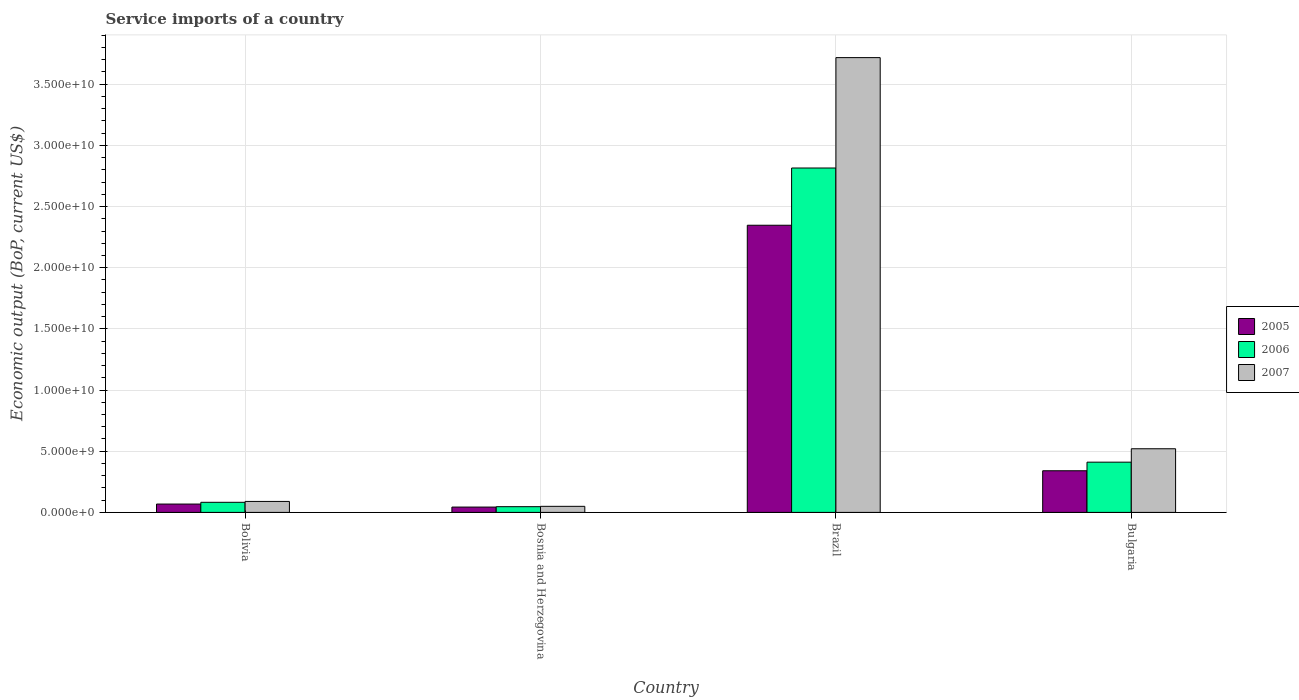How many different coloured bars are there?
Provide a short and direct response. 3. Are the number of bars on each tick of the X-axis equal?
Offer a very short reply. Yes. How many bars are there on the 2nd tick from the left?
Make the answer very short. 3. How many bars are there on the 1st tick from the right?
Keep it short and to the point. 3. What is the label of the 4th group of bars from the left?
Provide a short and direct response. Bulgaria. In how many cases, is the number of bars for a given country not equal to the number of legend labels?
Make the answer very short. 0. What is the service imports in 2007 in Bolivia?
Ensure brevity in your answer.  8.97e+08. Across all countries, what is the maximum service imports in 2007?
Make the answer very short. 3.72e+1. Across all countries, what is the minimum service imports in 2006?
Provide a succinct answer. 4.67e+08. In which country was the service imports in 2007 minimum?
Provide a succinct answer. Bosnia and Herzegovina. What is the total service imports in 2007 in the graph?
Your answer should be very brief. 4.38e+1. What is the difference between the service imports in 2005 in Bosnia and Herzegovina and that in Brazil?
Offer a terse response. -2.30e+1. What is the difference between the service imports in 2005 in Brazil and the service imports in 2006 in Bolivia?
Your answer should be compact. 2.26e+1. What is the average service imports in 2007 per country?
Your response must be concise. 1.09e+1. What is the difference between the service imports of/in 2005 and service imports of/in 2006 in Brazil?
Provide a succinct answer. -4.68e+09. What is the ratio of the service imports in 2007 in Bosnia and Herzegovina to that in Bulgaria?
Keep it short and to the point. 0.1. Is the difference between the service imports in 2005 in Bolivia and Bosnia and Herzegovina greater than the difference between the service imports in 2006 in Bolivia and Bosnia and Herzegovina?
Provide a succinct answer. No. What is the difference between the highest and the second highest service imports in 2006?
Provide a succinct answer. -3.28e+09. What is the difference between the highest and the lowest service imports in 2007?
Provide a succinct answer. 3.67e+1. In how many countries, is the service imports in 2006 greater than the average service imports in 2006 taken over all countries?
Offer a terse response. 1. What does the 1st bar from the right in Bolivia represents?
Make the answer very short. 2007. Is it the case that in every country, the sum of the service imports in 2005 and service imports in 2007 is greater than the service imports in 2006?
Make the answer very short. Yes. Are all the bars in the graph horizontal?
Provide a succinct answer. No. Are the values on the major ticks of Y-axis written in scientific E-notation?
Offer a very short reply. Yes. Does the graph contain any zero values?
Offer a very short reply. No. Does the graph contain grids?
Provide a short and direct response. Yes. How many legend labels are there?
Make the answer very short. 3. How are the legend labels stacked?
Your answer should be compact. Vertical. What is the title of the graph?
Your response must be concise. Service imports of a country. Does "1983" appear as one of the legend labels in the graph?
Offer a terse response. No. What is the label or title of the X-axis?
Your answer should be very brief. Country. What is the label or title of the Y-axis?
Offer a terse response. Economic output (BoP, current US$). What is the Economic output (BoP, current US$) of 2005 in Bolivia?
Your answer should be compact. 6.82e+08. What is the Economic output (BoP, current US$) of 2006 in Bolivia?
Your answer should be compact. 8.25e+08. What is the Economic output (BoP, current US$) of 2007 in Bolivia?
Offer a terse response. 8.97e+08. What is the Economic output (BoP, current US$) of 2005 in Bosnia and Herzegovina?
Make the answer very short. 4.36e+08. What is the Economic output (BoP, current US$) in 2006 in Bosnia and Herzegovina?
Your answer should be very brief. 4.67e+08. What is the Economic output (BoP, current US$) in 2007 in Bosnia and Herzegovina?
Your response must be concise. 4.95e+08. What is the Economic output (BoP, current US$) of 2005 in Brazil?
Your response must be concise. 2.35e+1. What is the Economic output (BoP, current US$) of 2006 in Brazil?
Your response must be concise. 2.81e+1. What is the Economic output (BoP, current US$) of 2007 in Brazil?
Provide a succinct answer. 3.72e+1. What is the Economic output (BoP, current US$) of 2005 in Bulgaria?
Give a very brief answer. 3.40e+09. What is the Economic output (BoP, current US$) of 2006 in Bulgaria?
Make the answer very short. 4.11e+09. What is the Economic output (BoP, current US$) in 2007 in Bulgaria?
Offer a very short reply. 5.20e+09. Across all countries, what is the maximum Economic output (BoP, current US$) in 2005?
Ensure brevity in your answer.  2.35e+1. Across all countries, what is the maximum Economic output (BoP, current US$) of 2006?
Give a very brief answer. 2.81e+1. Across all countries, what is the maximum Economic output (BoP, current US$) in 2007?
Ensure brevity in your answer.  3.72e+1. Across all countries, what is the minimum Economic output (BoP, current US$) in 2005?
Keep it short and to the point. 4.36e+08. Across all countries, what is the minimum Economic output (BoP, current US$) of 2006?
Make the answer very short. 4.67e+08. Across all countries, what is the minimum Economic output (BoP, current US$) in 2007?
Your answer should be very brief. 4.95e+08. What is the total Economic output (BoP, current US$) of 2005 in the graph?
Your answer should be very brief. 2.80e+1. What is the total Economic output (BoP, current US$) of 2006 in the graph?
Make the answer very short. 3.35e+1. What is the total Economic output (BoP, current US$) of 2007 in the graph?
Offer a very short reply. 4.38e+1. What is the difference between the Economic output (BoP, current US$) in 2005 in Bolivia and that in Bosnia and Herzegovina?
Your response must be concise. 2.46e+08. What is the difference between the Economic output (BoP, current US$) of 2006 in Bolivia and that in Bosnia and Herzegovina?
Offer a terse response. 3.58e+08. What is the difference between the Economic output (BoP, current US$) of 2007 in Bolivia and that in Bosnia and Herzegovina?
Keep it short and to the point. 4.01e+08. What is the difference between the Economic output (BoP, current US$) in 2005 in Bolivia and that in Brazil?
Your answer should be compact. -2.28e+1. What is the difference between the Economic output (BoP, current US$) in 2006 in Bolivia and that in Brazil?
Ensure brevity in your answer.  -2.73e+1. What is the difference between the Economic output (BoP, current US$) in 2007 in Bolivia and that in Brazil?
Offer a very short reply. -3.63e+1. What is the difference between the Economic output (BoP, current US$) in 2005 in Bolivia and that in Bulgaria?
Give a very brief answer. -2.72e+09. What is the difference between the Economic output (BoP, current US$) in 2006 in Bolivia and that in Bulgaria?
Ensure brevity in your answer.  -3.28e+09. What is the difference between the Economic output (BoP, current US$) of 2007 in Bolivia and that in Bulgaria?
Keep it short and to the point. -4.31e+09. What is the difference between the Economic output (BoP, current US$) in 2005 in Bosnia and Herzegovina and that in Brazil?
Provide a succinct answer. -2.30e+1. What is the difference between the Economic output (BoP, current US$) of 2006 in Bosnia and Herzegovina and that in Brazil?
Offer a very short reply. -2.77e+1. What is the difference between the Economic output (BoP, current US$) in 2007 in Bosnia and Herzegovina and that in Brazil?
Give a very brief answer. -3.67e+1. What is the difference between the Economic output (BoP, current US$) in 2005 in Bosnia and Herzegovina and that in Bulgaria?
Provide a short and direct response. -2.97e+09. What is the difference between the Economic output (BoP, current US$) in 2006 in Bosnia and Herzegovina and that in Bulgaria?
Provide a succinct answer. -3.64e+09. What is the difference between the Economic output (BoP, current US$) in 2007 in Bosnia and Herzegovina and that in Bulgaria?
Give a very brief answer. -4.71e+09. What is the difference between the Economic output (BoP, current US$) of 2005 in Brazil and that in Bulgaria?
Your answer should be compact. 2.01e+1. What is the difference between the Economic output (BoP, current US$) in 2006 in Brazil and that in Bulgaria?
Offer a terse response. 2.40e+1. What is the difference between the Economic output (BoP, current US$) of 2007 in Brazil and that in Bulgaria?
Your response must be concise. 3.20e+1. What is the difference between the Economic output (BoP, current US$) of 2005 in Bolivia and the Economic output (BoP, current US$) of 2006 in Bosnia and Herzegovina?
Offer a terse response. 2.15e+08. What is the difference between the Economic output (BoP, current US$) in 2005 in Bolivia and the Economic output (BoP, current US$) in 2007 in Bosnia and Herzegovina?
Ensure brevity in your answer.  1.87e+08. What is the difference between the Economic output (BoP, current US$) in 2006 in Bolivia and the Economic output (BoP, current US$) in 2007 in Bosnia and Herzegovina?
Make the answer very short. 3.29e+08. What is the difference between the Economic output (BoP, current US$) of 2005 in Bolivia and the Economic output (BoP, current US$) of 2006 in Brazil?
Offer a very short reply. -2.75e+1. What is the difference between the Economic output (BoP, current US$) in 2005 in Bolivia and the Economic output (BoP, current US$) in 2007 in Brazil?
Your answer should be compact. -3.65e+1. What is the difference between the Economic output (BoP, current US$) of 2006 in Bolivia and the Economic output (BoP, current US$) of 2007 in Brazil?
Your answer should be compact. -3.63e+1. What is the difference between the Economic output (BoP, current US$) in 2005 in Bolivia and the Economic output (BoP, current US$) in 2006 in Bulgaria?
Provide a succinct answer. -3.42e+09. What is the difference between the Economic output (BoP, current US$) of 2005 in Bolivia and the Economic output (BoP, current US$) of 2007 in Bulgaria?
Offer a terse response. -4.52e+09. What is the difference between the Economic output (BoP, current US$) in 2006 in Bolivia and the Economic output (BoP, current US$) in 2007 in Bulgaria?
Keep it short and to the point. -4.38e+09. What is the difference between the Economic output (BoP, current US$) of 2005 in Bosnia and Herzegovina and the Economic output (BoP, current US$) of 2006 in Brazil?
Provide a short and direct response. -2.77e+1. What is the difference between the Economic output (BoP, current US$) of 2005 in Bosnia and Herzegovina and the Economic output (BoP, current US$) of 2007 in Brazil?
Provide a short and direct response. -3.67e+1. What is the difference between the Economic output (BoP, current US$) in 2006 in Bosnia and Herzegovina and the Economic output (BoP, current US$) in 2007 in Brazil?
Your response must be concise. -3.67e+1. What is the difference between the Economic output (BoP, current US$) of 2005 in Bosnia and Herzegovina and the Economic output (BoP, current US$) of 2006 in Bulgaria?
Offer a terse response. -3.67e+09. What is the difference between the Economic output (BoP, current US$) in 2005 in Bosnia and Herzegovina and the Economic output (BoP, current US$) in 2007 in Bulgaria?
Your response must be concise. -4.77e+09. What is the difference between the Economic output (BoP, current US$) of 2006 in Bosnia and Herzegovina and the Economic output (BoP, current US$) of 2007 in Bulgaria?
Your answer should be very brief. -4.74e+09. What is the difference between the Economic output (BoP, current US$) of 2005 in Brazil and the Economic output (BoP, current US$) of 2006 in Bulgaria?
Your answer should be very brief. 1.94e+1. What is the difference between the Economic output (BoP, current US$) of 2005 in Brazil and the Economic output (BoP, current US$) of 2007 in Bulgaria?
Offer a very short reply. 1.83e+1. What is the difference between the Economic output (BoP, current US$) of 2006 in Brazil and the Economic output (BoP, current US$) of 2007 in Bulgaria?
Your answer should be compact. 2.29e+1. What is the average Economic output (BoP, current US$) of 2005 per country?
Provide a succinct answer. 7.00e+09. What is the average Economic output (BoP, current US$) in 2006 per country?
Provide a succinct answer. 8.39e+09. What is the average Economic output (BoP, current US$) in 2007 per country?
Ensure brevity in your answer.  1.09e+1. What is the difference between the Economic output (BoP, current US$) of 2005 and Economic output (BoP, current US$) of 2006 in Bolivia?
Provide a short and direct response. -1.43e+08. What is the difference between the Economic output (BoP, current US$) of 2005 and Economic output (BoP, current US$) of 2007 in Bolivia?
Provide a succinct answer. -2.15e+08. What is the difference between the Economic output (BoP, current US$) of 2006 and Economic output (BoP, current US$) of 2007 in Bolivia?
Your answer should be very brief. -7.19e+07. What is the difference between the Economic output (BoP, current US$) of 2005 and Economic output (BoP, current US$) of 2006 in Bosnia and Herzegovina?
Offer a very short reply. -3.12e+07. What is the difference between the Economic output (BoP, current US$) in 2005 and Economic output (BoP, current US$) in 2007 in Bosnia and Herzegovina?
Offer a very short reply. -5.97e+07. What is the difference between the Economic output (BoP, current US$) of 2006 and Economic output (BoP, current US$) of 2007 in Bosnia and Herzegovina?
Offer a terse response. -2.86e+07. What is the difference between the Economic output (BoP, current US$) in 2005 and Economic output (BoP, current US$) in 2006 in Brazil?
Offer a very short reply. -4.68e+09. What is the difference between the Economic output (BoP, current US$) in 2005 and Economic output (BoP, current US$) in 2007 in Brazil?
Provide a succinct answer. -1.37e+1. What is the difference between the Economic output (BoP, current US$) in 2006 and Economic output (BoP, current US$) in 2007 in Brazil?
Your answer should be compact. -9.02e+09. What is the difference between the Economic output (BoP, current US$) in 2005 and Economic output (BoP, current US$) in 2006 in Bulgaria?
Make the answer very short. -7.02e+08. What is the difference between the Economic output (BoP, current US$) in 2005 and Economic output (BoP, current US$) in 2007 in Bulgaria?
Your response must be concise. -1.80e+09. What is the difference between the Economic output (BoP, current US$) in 2006 and Economic output (BoP, current US$) in 2007 in Bulgaria?
Offer a terse response. -1.10e+09. What is the ratio of the Economic output (BoP, current US$) of 2005 in Bolivia to that in Bosnia and Herzegovina?
Make the answer very short. 1.57. What is the ratio of the Economic output (BoP, current US$) in 2006 in Bolivia to that in Bosnia and Herzegovina?
Your answer should be very brief. 1.77. What is the ratio of the Economic output (BoP, current US$) in 2007 in Bolivia to that in Bosnia and Herzegovina?
Give a very brief answer. 1.81. What is the ratio of the Economic output (BoP, current US$) of 2005 in Bolivia to that in Brazil?
Give a very brief answer. 0.03. What is the ratio of the Economic output (BoP, current US$) in 2006 in Bolivia to that in Brazil?
Offer a terse response. 0.03. What is the ratio of the Economic output (BoP, current US$) of 2007 in Bolivia to that in Brazil?
Keep it short and to the point. 0.02. What is the ratio of the Economic output (BoP, current US$) of 2005 in Bolivia to that in Bulgaria?
Provide a succinct answer. 0.2. What is the ratio of the Economic output (BoP, current US$) in 2006 in Bolivia to that in Bulgaria?
Make the answer very short. 0.2. What is the ratio of the Economic output (BoP, current US$) in 2007 in Bolivia to that in Bulgaria?
Give a very brief answer. 0.17. What is the ratio of the Economic output (BoP, current US$) of 2005 in Bosnia and Herzegovina to that in Brazil?
Keep it short and to the point. 0.02. What is the ratio of the Economic output (BoP, current US$) of 2006 in Bosnia and Herzegovina to that in Brazil?
Keep it short and to the point. 0.02. What is the ratio of the Economic output (BoP, current US$) in 2007 in Bosnia and Herzegovina to that in Brazil?
Offer a very short reply. 0.01. What is the ratio of the Economic output (BoP, current US$) of 2005 in Bosnia and Herzegovina to that in Bulgaria?
Offer a terse response. 0.13. What is the ratio of the Economic output (BoP, current US$) in 2006 in Bosnia and Herzegovina to that in Bulgaria?
Your answer should be very brief. 0.11. What is the ratio of the Economic output (BoP, current US$) of 2007 in Bosnia and Herzegovina to that in Bulgaria?
Your answer should be very brief. 0.1. What is the ratio of the Economic output (BoP, current US$) in 2005 in Brazil to that in Bulgaria?
Offer a terse response. 6.9. What is the ratio of the Economic output (BoP, current US$) in 2006 in Brazil to that in Bulgaria?
Offer a very short reply. 6.86. What is the ratio of the Economic output (BoP, current US$) in 2007 in Brazil to that in Bulgaria?
Your answer should be very brief. 7.15. What is the difference between the highest and the second highest Economic output (BoP, current US$) in 2005?
Keep it short and to the point. 2.01e+1. What is the difference between the highest and the second highest Economic output (BoP, current US$) in 2006?
Provide a succinct answer. 2.40e+1. What is the difference between the highest and the second highest Economic output (BoP, current US$) of 2007?
Ensure brevity in your answer.  3.20e+1. What is the difference between the highest and the lowest Economic output (BoP, current US$) of 2005?
Ensure brevity in your answer.  2.30e+1. What is the difference between the highest and the lowest Economic output (BoP, current US$) of 2006?
Your answer should be compact. 2.77e+1. What is the difference between the highest and the lowest Economic output (BoP, current US$) of 2007?
Make the answer very short. 3.67e+1. 